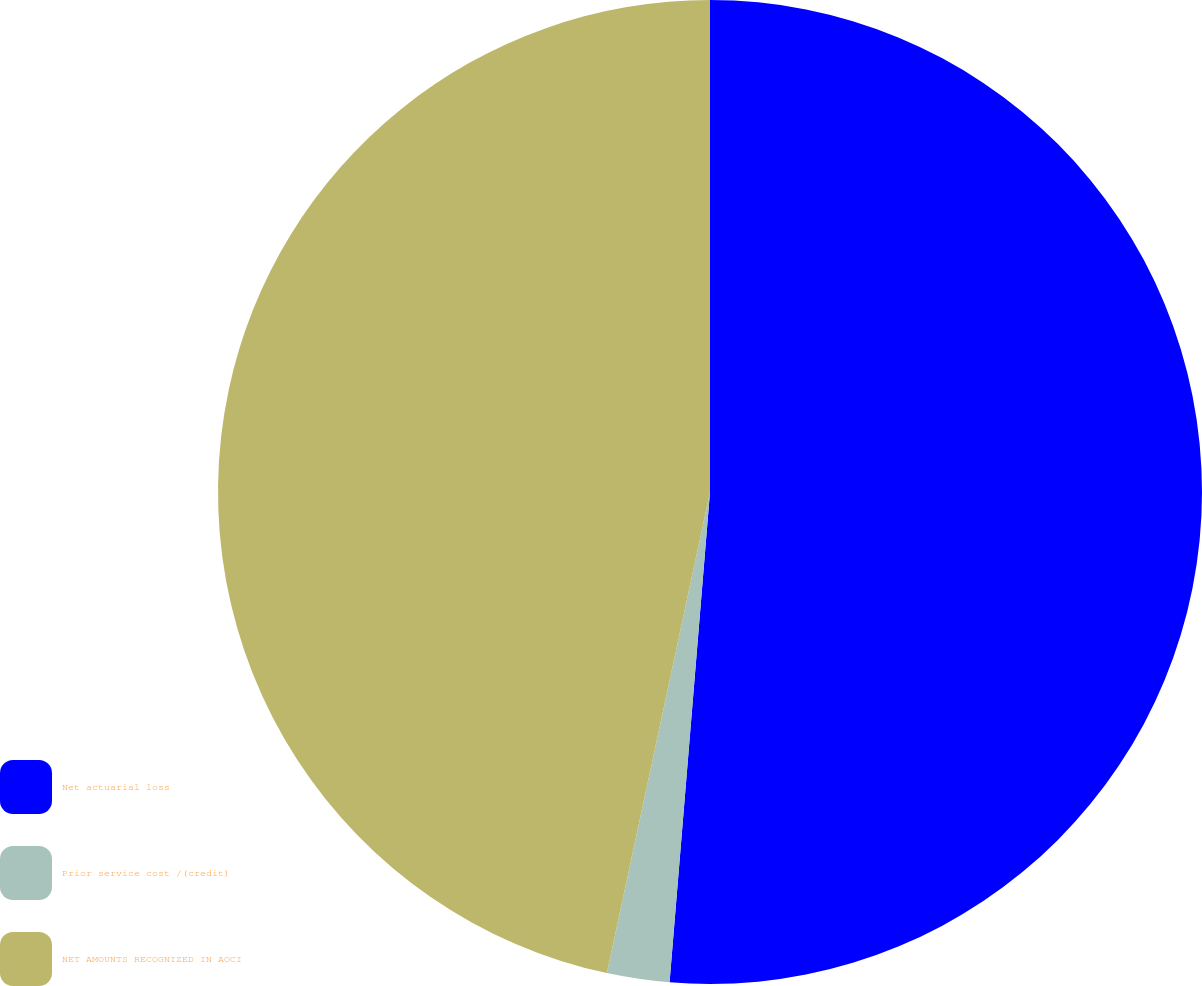<chart> <loc_0><loc_0><loc_500><loc_500><pie_chart><fcel>Net actuarial loss<fcel>Prior service cost /(credit)<fcel>NET AMOUNTS RECOGNIZED IN AOCI<nl><fcel>51.31%<fcel>2.05%<fcel>46.64%<nl></chart> 